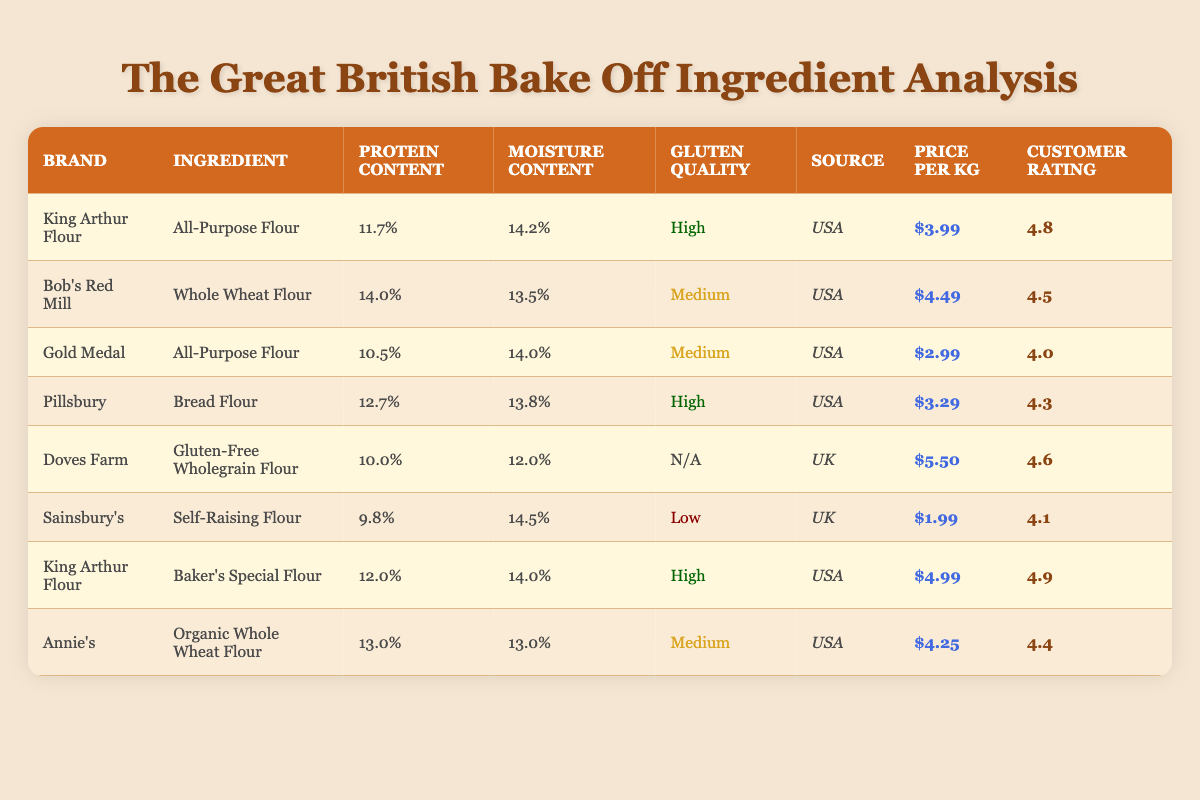What is the protein content of Gold Medal's All-Purpose Flour? The table shows that Gold Medal's All-Purpose Flour has a protein content listed as 10.5%.
Answer: 10.5% Which brand has the highest customer rating? Looking through the customer ratings in the table, King Arthur Flour's Baker's Special Flour has the highest rating at 4.9.
Answer: 4.9 Is the moisture content of Doves Farm's Gluten-Free Wholegrain Flour higher than 14%? The table indicates that Doves Farm's Gluten-Free Wholegrain Flour has a moisture content of 12.0%, which is lower than 14%.
Answer: No What is the average price per kg of all the brands listed? Summing the prices ($3.99 + $4.49 + $2.99 + $3.29 + $5.50 + $1.99 + $4.99 + $4.25) gives $31.49 for 8 brands. Dividing by 8 results in an average price of approximately $3.94.
Answer: $3.94 Which brand offers the highest protein content and what is that content? Analyzing the table, Bob's Red Mill Whole Wheat Flour has the highest protein content at 14.0%.
Answer: 14.0% Does any brand have a gluten quality marked as "N/A"? Yes, the table indicates that Doves Farm's Gluten-Free Wholegrain Flour has a gluten quality marked as "N/A".
Answer: Yes What is the price difference between Sainsbury's Self-Raising Flour and Gold Medal's All-Purpose Flour? Sainsbury's Self-Raising Flour costs $1.99, while Gold Medal's All-Purpose Flour is $2.99. The difference is calculated as $2.99 - $1.99 = $1.00.
Answer: $1.00 How many brands have a gluten quality labeled as "High"? Upon reviewing the table, King Arthur Flour (All-Purpose Flour), Pillsbury (Bread Flour), and King Arthur Flour (Baker's Special Flour) all have a gluten quality labeled as "High", making a total of three brands.
Answer: 3 What is the source of Annie's Organic Whole Wheat Flour? The table provides that Annie’s Organic Whole Wheat Flour comes from the USA.
Answer: USA 